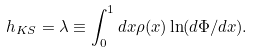<formula> <loc_0><loc_0><loc_500><loc_500>h _ { K S } = \lambda \equiv \int _ { 0 } ^ { 1 } d x \rho ( x ) \ln ( d \Phi / d x ) .</formula> 